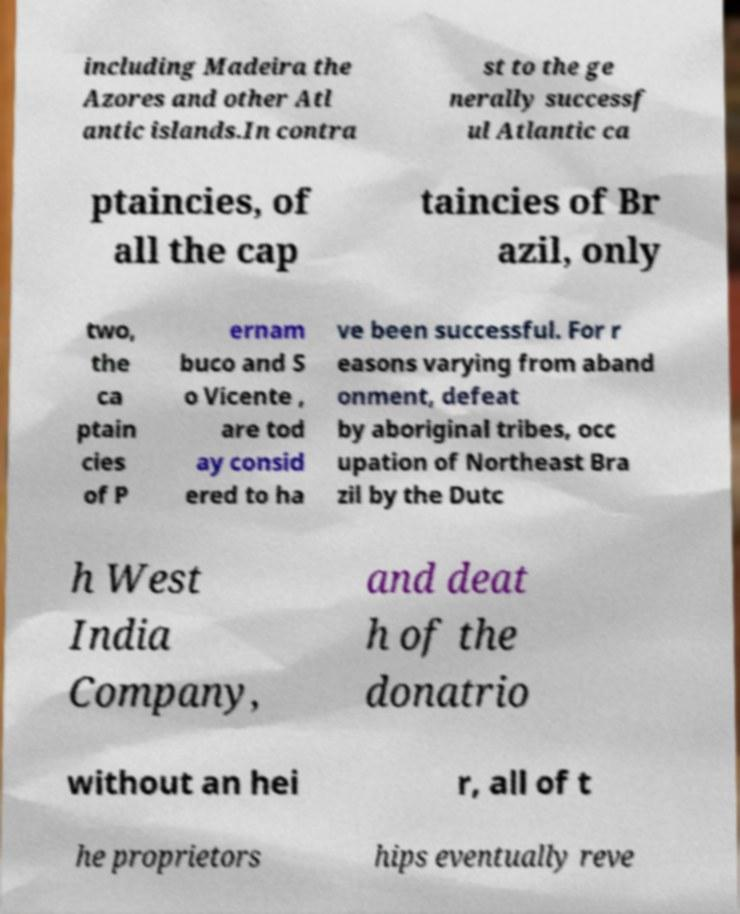There's text embedded in this image that I need extracted. Can you transcribe it verbatim? including Madeira the Azores and other Atl antic islands.In contra st to the ge nerally successf ul Atlantic ca ptaincies, of all the cap taincies of Br azil, only two, the ca ptain cies of P ernam buco and S o Vicente , are tod ay consid ered to ha ve been successful. For r easons varying from aband onment, defeat by aboriginal tribes, occ upation of Northeast Bra zil by the Dutc h West India Company, and deat h of the donatrio without an hei r, all of t he proprietors hips eventually reve 